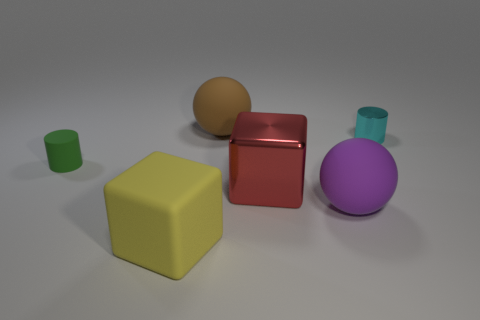There is another cyan object that is the same shape as the small rubber object; what is it made of?
Offer a terse response. Metal. What is the color of the big rubber sphere in front of the shiny thing behind the big cube that is behind the yellow object?
Make the answer very short. Purple. Is there any other thing that has the same color as the tiny matte object?
Keep it short and to the point. No. What is the size of the brown matte ball behind the cyan shiny object?
Offer a very short reply. Large. What is the shape of the purple matte object that is the same size as the brown matte sphere?
Your answer should be compact. Sphere. Is the material of the tiny cylinder on the left side of the big purple matte ball the same as the tiny cylinder right of the yellow object?
Ensure brevity in your answer.  No. What is the material of the tiny cylinder on the right side of the sphere that is in front of the tiny cyan cylinder?
Provide a short and direct response. Metal. How big is the ball that is in front of the small cylinder to the right of the cylinder on the left side of the big red shiny cube?
Your answer should be very brief. Large. Do the purple sphere and the red shiny thing have the same size?
Offer a very short reply. Yes. Do the tiny thing on the left side of the big red thing and the brown object to the left of the tiny cyan shiny thing have the same shape?
Offer a very short reply. No. 